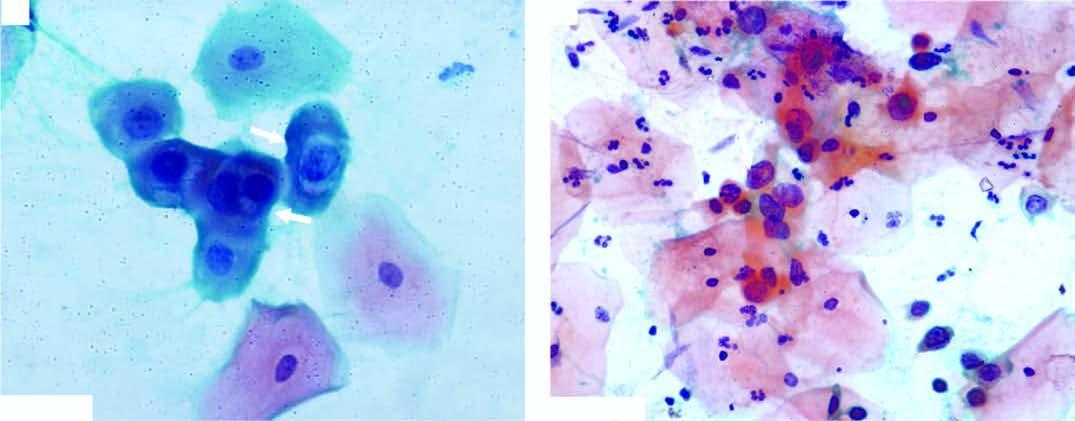what do the squamous cells have?
Answer the question using a single word or phrase. Scanty cytoplasm and markedly hyperchromatic nuclei having irregular nuclear outlines 